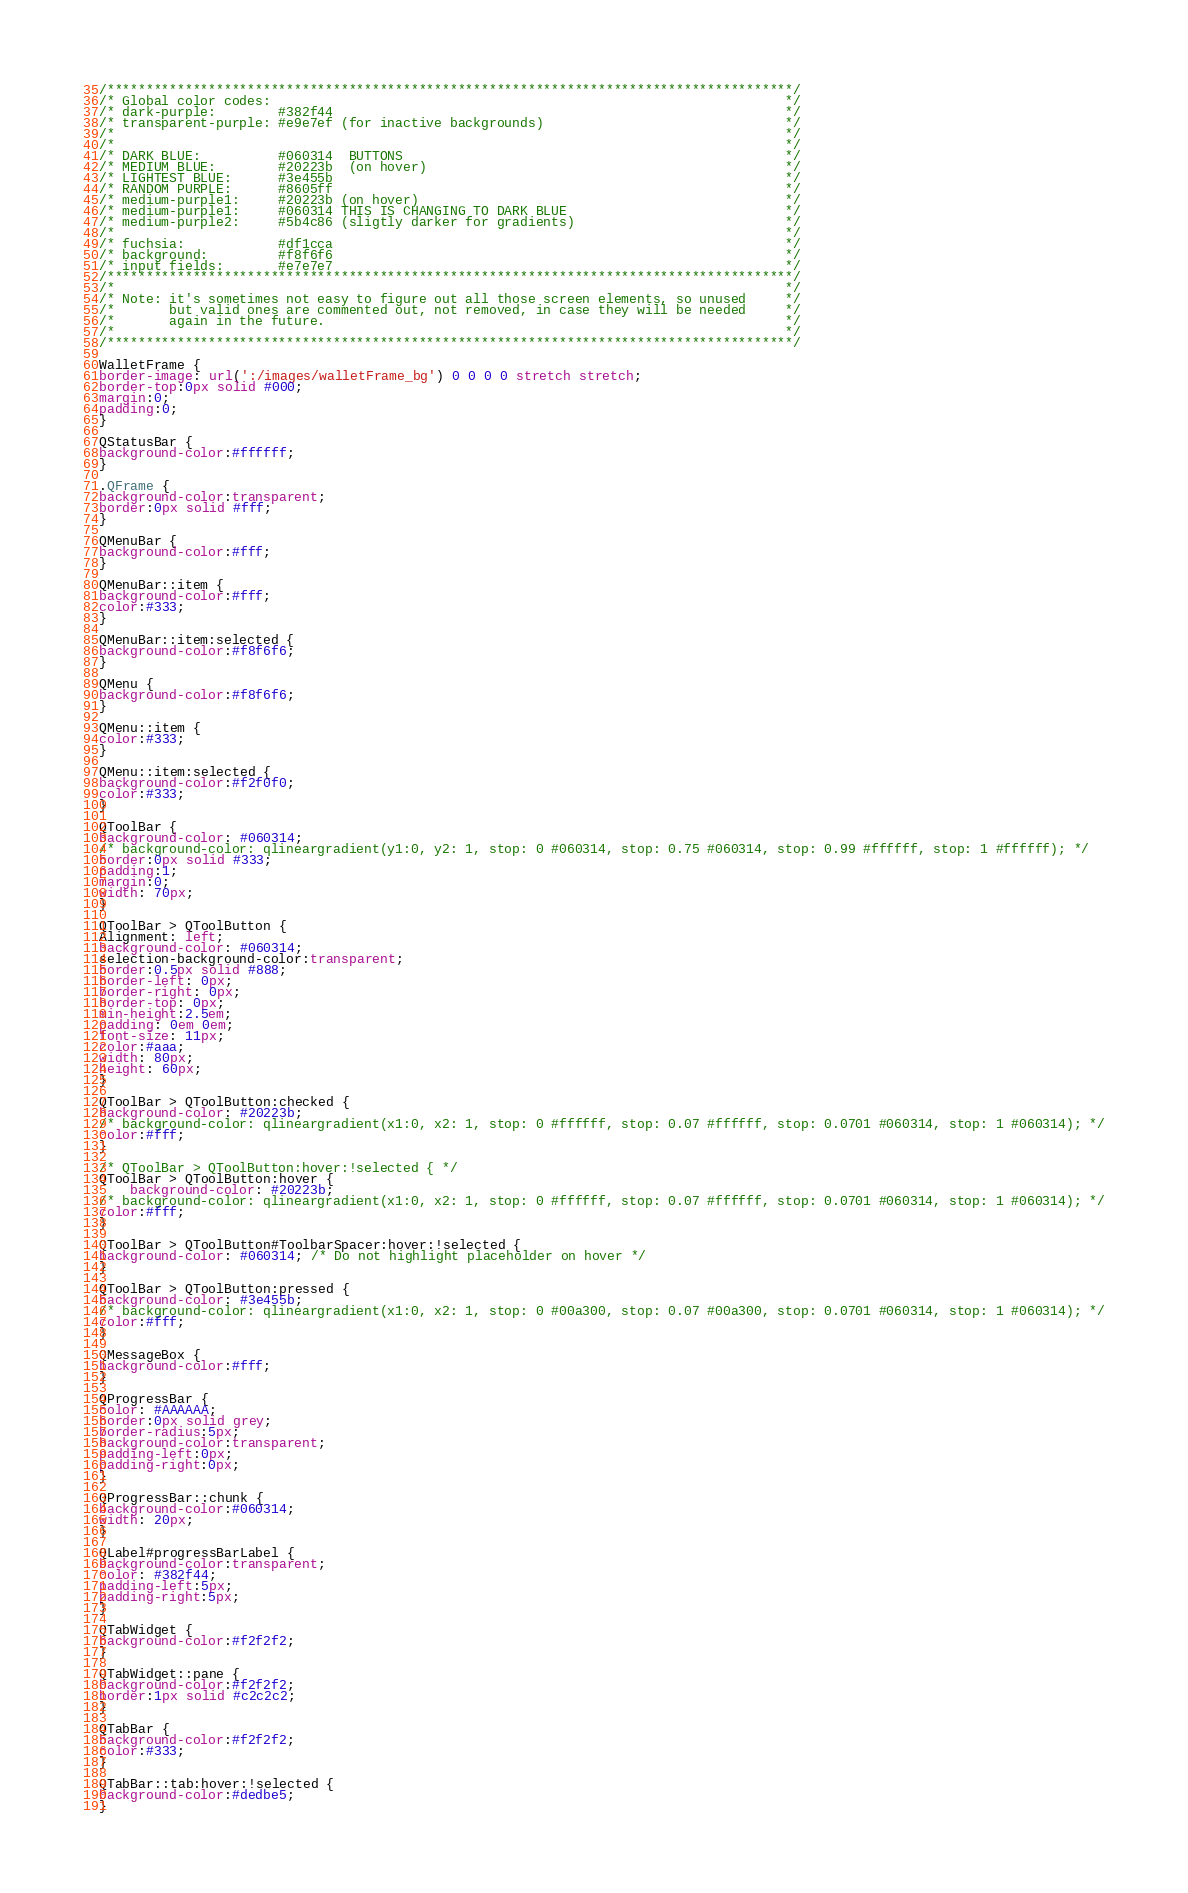<code> <loc_0><loc_0><loc_500><loc_500><_CSS_>/****************************************************************************************/
/* Global color codes:                                                                  */
/* dark-purple:        #382f44                                                          */
/* transparent-purple: #e9e7ef (for inactive backgrounds)                               */
/*                                                                                      */
/*                                                                                      */
/* DARK BLUE:          #060314  BUTTONS                                                 */
/* MEDIUM BLUE:        #20223b  (on hover)                                              */
/* LIGHTEST BLUE:      #3e455b                                                          */
/* RANDOM PURPLE:      #8605ff                                                          */
/* medium-purple1:     #20223b (on hover)                                               */
/* medium-purple1:     #060314 THIS IS CHANGING TO DARK BLUE                            */
/* medium-purple2:     #5b4c86 (sligtly darker for gradients)                           */
/*                                                                                      */
/* fuchsia:            #df1cca                                                          */
/* background:         #f8f6f6                                                          */
/* input fields:       #e7e7e7                                                          */
/****************************************************************************************/
/*                                                                                      */
/* Note: it's sometimes not easy to figure out all those screen elements, so unused     */
/*       but valid ones are commented out, not removed, in case they will be needed     */
/*       again in the future.                                                           */
/*                                                                                      */
/****************************************************************************************/

WalletFrame {
border-image: url(':/images/walletFrame_bg') 0 0 0 0 stretch stretch;
border-top:0px solid #000;
margin:0;
padding:0;
}

QStatusBar {
background-color:#ffffff;
}

.QFrame {
background-color:transparent;
border:0px solid #fff;
}

QMenuBar {
background-color:#fff;
}

QMenuBar::item {
background-color:#fff;
color:#333;
}

QMenuBar::item:selected {
background-color:#f8f6f6;
}

QMenu {
background-color:#f8f6f6;
}

QMenu::item {
color:#333;
}

QMenu::item:selected {
background-color:#f2f0f0;
color:#333;
}

QToolBar {
background-color: #060314;
/* background-color: qlineargradient(y1:0, y2: 1, stop: 0 #060314, stop: 0.75 #060314, stop: 0.99 #ffffff, stop: 1 #ffffff); */
border:0px solid #333;
padding:1;
margin:0;
width: 70px;
}

QToolBar > QToolButton {
Alignment: left;
background-color: #060314;
selection-background-color:transparent;
border:0.5px solid #888;
border-left: 0px;
border-right: 0px;
border-top: 0px;
min-height:2.5em;
padding: 0em 0em;
font-size: 11px;
color:#aaa;
width: 80px;
height: 60px;
}

QToolBar > QToolButton:checked {
background-color: #20223b;
/* background-color: qlineargradient(x1:0, x2: 1, stop: 0 #ffffff, stop: 0.07 #ffffff, stop: 0.0701 #060314, stop: 1 #060314); */
color:#fff;
}

/* QToolBar > QToolButton:hover:!selected { */
QToolBar > QToolButton:hover {
    background-color: #20223b;
/* background-color: qlineargradient(x1:0, x2: 1, stop: 0 #ffffff, stop: 0.07 #ffffff, stop: 0.0701 #060314, stop: 1 #060314); */
color:#fff;
}

QToolBar > QToolButton#ToolbarSpacer:hover:!selected {
background-color: #060314; /* Do not highlight placeholder on hover */
}

QToolBar > QToolButton:pressed {
background-color: #3e455b;
/* background-color: qlineargradient(x1:0, x2: 1, stop: 0 #00a300, stop: 0.07 #00a300, stop: 0.0701 #060314, stop: 1 #060314); */
color:#fff;
}

QMessageBox {
background-color:#fff;
}

QProgressBar {
color: #AAAAAA;
border:0px solid grey;
border-radius:5px;
background-color:transparent;
padding-left:0px;
padding-right:0px;
}

QProgressBar::chunk {
background-color:#060314;
width: 20px;
}

QLabel#progressBarLabel {
background-color:transparent;
color: #382f44;
padding-left:5px;
padding-right:5px;
}

QTabWidget {
background-color:#f2f2f2;
}

QTabWidget::pane {
background-color:#f2f2f2;
border:1px solid #c2c2c2;
}

QTabBar {
background-color:#f2f2f2;
color:#333;
}

QTabBar::tab:hover:!selected {
background-color:#dedbe5;
}
</code> 